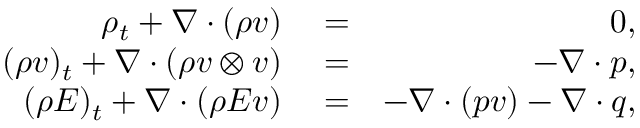Convert formula to latex. <formula><loc_0><loc_0><loc_500><loc_500>\begin{array} { r l r } { \rho _ { t } + \nabla \cdot ( \rho v ) } & = } & { 0 , } \\ { ( \rho v ) _ { t } + \nabla \cdot ( \rho v \otimes v ) } & = } & { - \nabla \cdot p , } \\ { ( \rho E ) _ { t } + \nabla \cdot ( \rho E v ) } & = } & { - \nabla \cdot ( p v ) - \nabla \cdot q , } \end{array}</formula> 